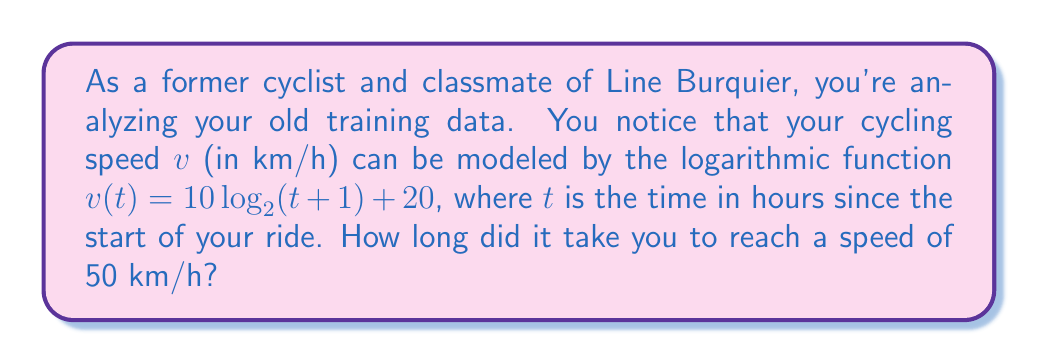Could you help me with this problem? To solve this problem, we need to use the given logarithmic function and solve for $t$ when $v = 50$ km/h. Let's break it down step by step:

1) We start with the equation: $v(t) = 10 \log_2(t+1) + 20$

2) We want to find $t$ when $v = 50$, so we substitute this:
   
   $50 = 10 \log_2(t+1) + 20$

3) Subtract 20 from both sides:
   
   $30 = 10 \log_2(t+1)$

4) Divide both sides by 10:
   
   $3 = \log_2(t+1)$

5) To solve for $t$, we need to apply the inverse function (exponential) to both sides:
   
   $2^3 = t+1$

6) Simplify the left side:
   
   $8 = t+1$

7) Subtract 1 from both sides to isolate $t$:
   
   $7 = t$

Therefore, it took 7 hours to reach a speed of 50 km/h.
Answer: $t = 7$ hours 